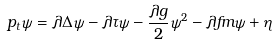Convert formula to latex. <formula><loc_0><loc_0><loc_500><loc_500>\ p _ { t } \psi = \lambda \Delta \psi - \lambda \tau \psi - \frac { \lambda g } { 2 } \psi ^ { 2 } - \lambda f m \psi + \eta</formula> 